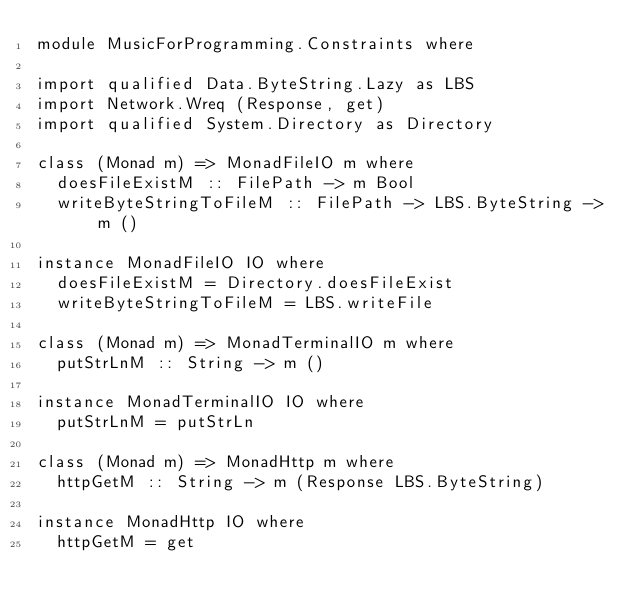Convert code to text. <code><loc_0><loc_0><loc_500><loc_500><_Haskell_>module MusicForProgramming.Constraints where

import qualified Data.ByteString.Lazy as LBS
import Network.Wreq (Response, get)
import qualified System.Directory as Directory

class (Monad m) => MonadFileIO m where
  doesFileExistM :: FilePath -> m Bool
  writeByteStringToFileM :: FilePath -> LBS.ByteString -> m ()

instance MonadFileIO IO where
  doesFileExistM = Directory.doesFileExist
  writeByteStringToFileM = LBS.writeFile

class (Monad m) => MonadTerminalIO m where
  putStrLnM :: String -> m ()

instance MonadTerminalIO IO where
  putStrLnM = putStrLn

class (Monad m) => MonadHttp m where
  httpGetM :: String -> m (Response LBS.ByteString)

instance MonadHttp IO where
  httpGetM = get
</code> 